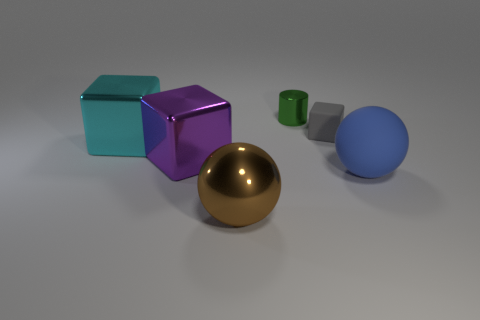Subtract all large metal blocks. How many blocks are left? 1 Subtract 2 blocks. How many blocks are left? 1 Subtract all cyan cubes. How many cubes are left? 2 Add 2 big green cylinders. How many objects exist? 8 Add 5 purple blocks. How many purple blocks exist? 6 Subtract 0 cyan cylinders. How many objects are left? 6 Subtract all cylinders. How many objects are left? 5 Subtract all blue cubes. Subtract all green balls. How many cubes are left? 3 Subtract all green blocks. How many gray cylinders are left? 0 Subtract all purple cubes. Subtract all tiny green shiny objects. How many objects are left? 4 